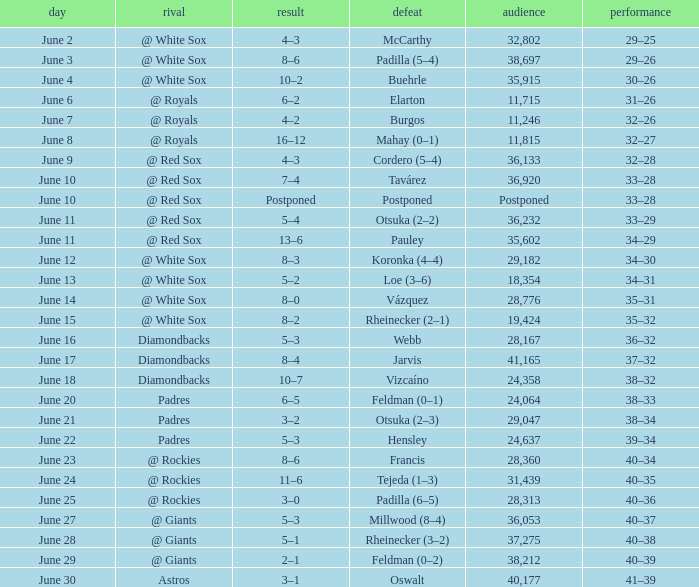When did tavárez lose? June 10. 